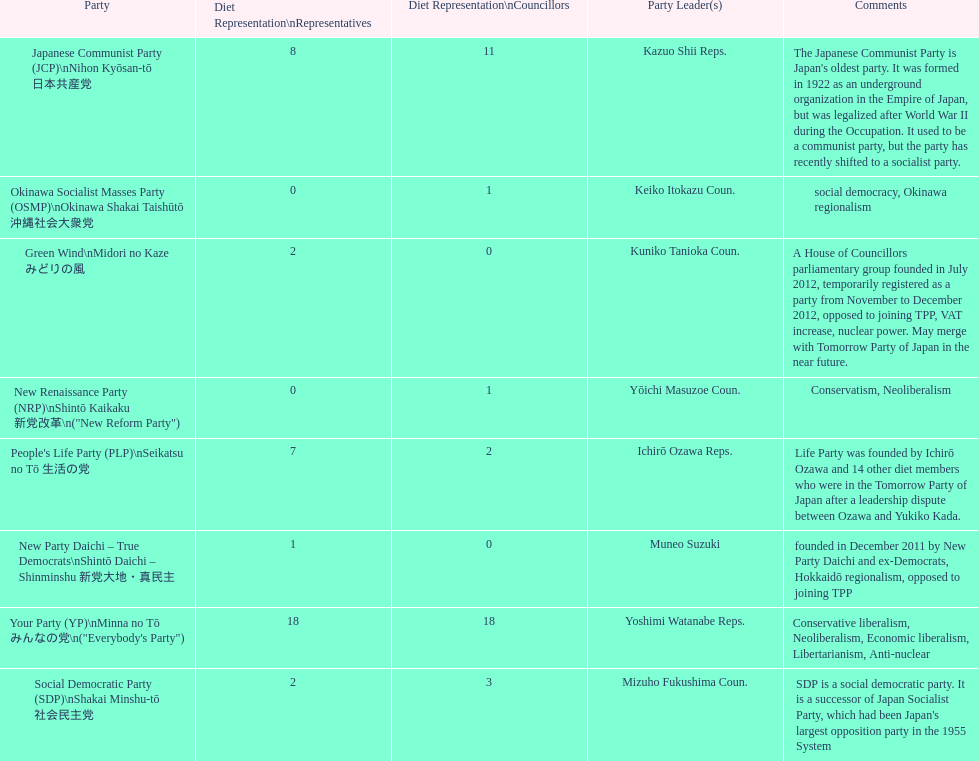How many representatives come from the green wind party? 2. 